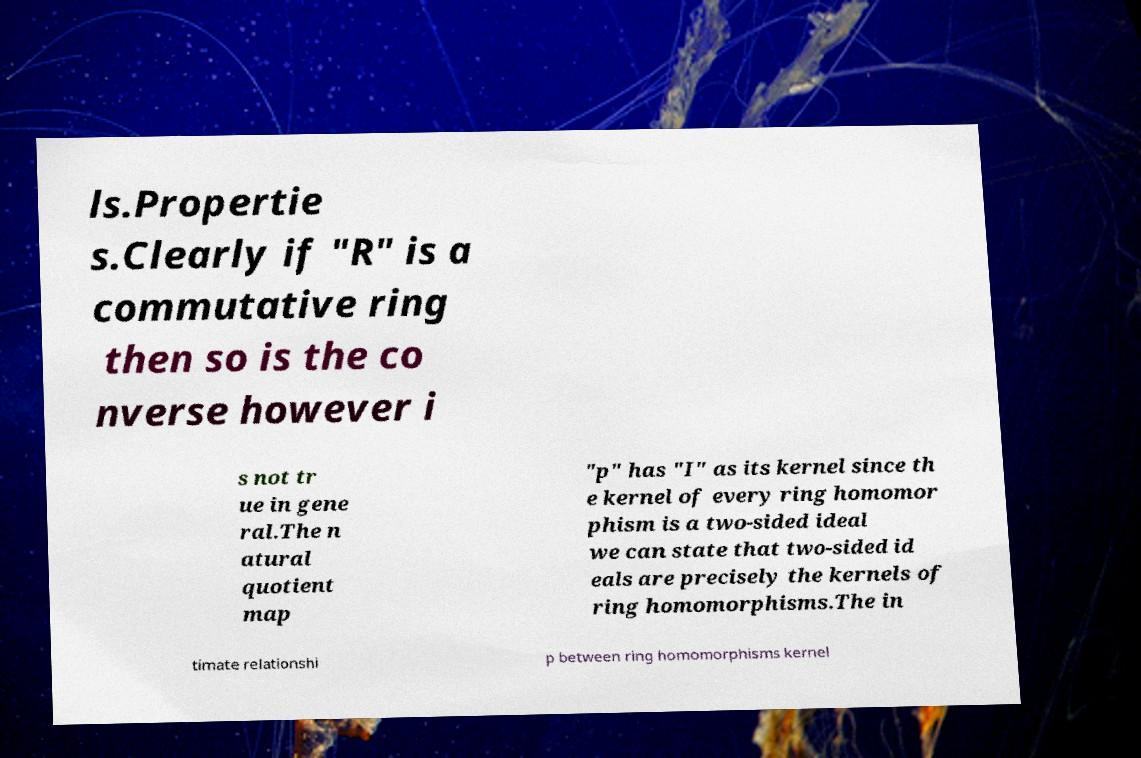There's text embedded in this image that I need extracted. Can you transcribe it verbatim? ls.Propertie s.Clearly if "R" is a commutative ring then so is the co nverse however i s not tr ue in gene ral.The n atural quotient map "p" has "I" as its kernel since th e kernel of every ring homomor phism is a two-sided ideal we can state that two-sided id eals are precisely the kernels of ring homomorphisms.The in timate relationshi p between ring homomorphisms kernel 